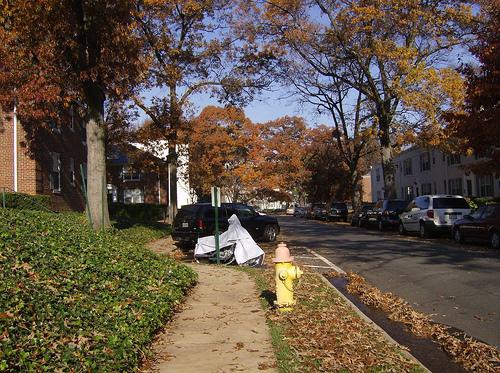What is under the white cover?
Short answer required. Motorcycle. What kind of walkway is this?
Keep it brief. Sidewalk. Is this scene in America?
Answer briefly. Yes. Is this a rural scene?
Be succinct. No. Is it daytime?
Concise answer only. Yes. What season is it?
Write a very short answer. Fall. 